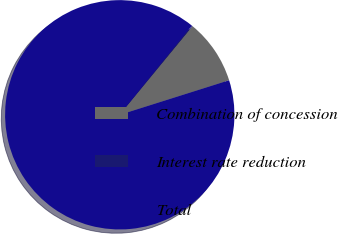Convert chart. <chart><loc_0><loc_0><loc_500><loc_500><pie_chart><fcel>Combination of concession<fcel>Interest rate reduction<fcel>Total<nl><fcel>9.18%<fcel>0.12%<fcel>90.7%<nl></chart> 